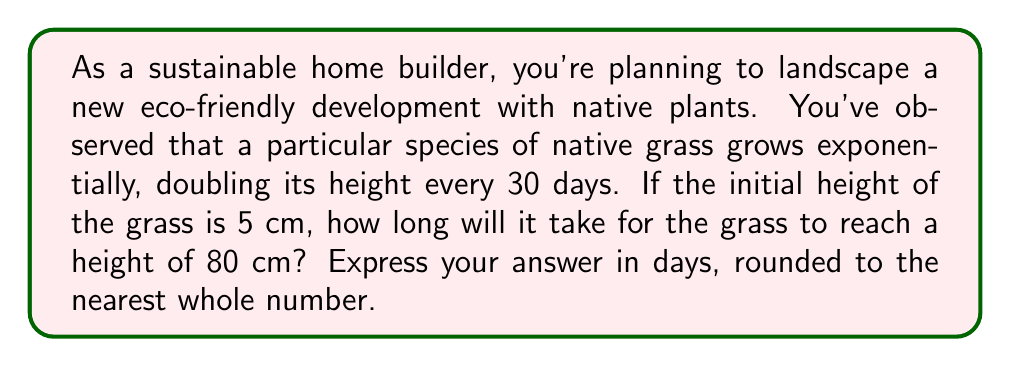Solve this math problem. Let's approach this problem step-by-step using an exponential model and logarithms:

1) We can model the height of the grass with the exponential function:

   $h(t) = 5 \cdot 2^{t/30}$

   Where $h(t)$ is the height in cm after $t$ days, 5 is the initial height, and the grass doubles every 30 days.

2) We want to find $t$ when $h(t) = 80$. So, we set up the equation:

   $80 = 5 \cdot 2^{t/30}$

3) Divide both sides by 5:

   $16 = 2^{t/30}$

4) Now, we can apply logarithms to both sides. Since the base is 2, we'll use log base 2:

   $\log_2(16) = \log_2(2^{t/30})$

5) The right side simplifies due to the logarithm rule $\log_a(a^x) = x$:

   $\log_2(16) = t/30$

6) We know that $\log_2(16) = 4$ because $2^4 = 16$. So:

   $4 = t/30$

7) Solve for $t$:

   $t = 4 \cdot 30 = 120$

Therefore, it will take 120 days for the grass to reach a height of 80 cm.
Answer: 120 days 